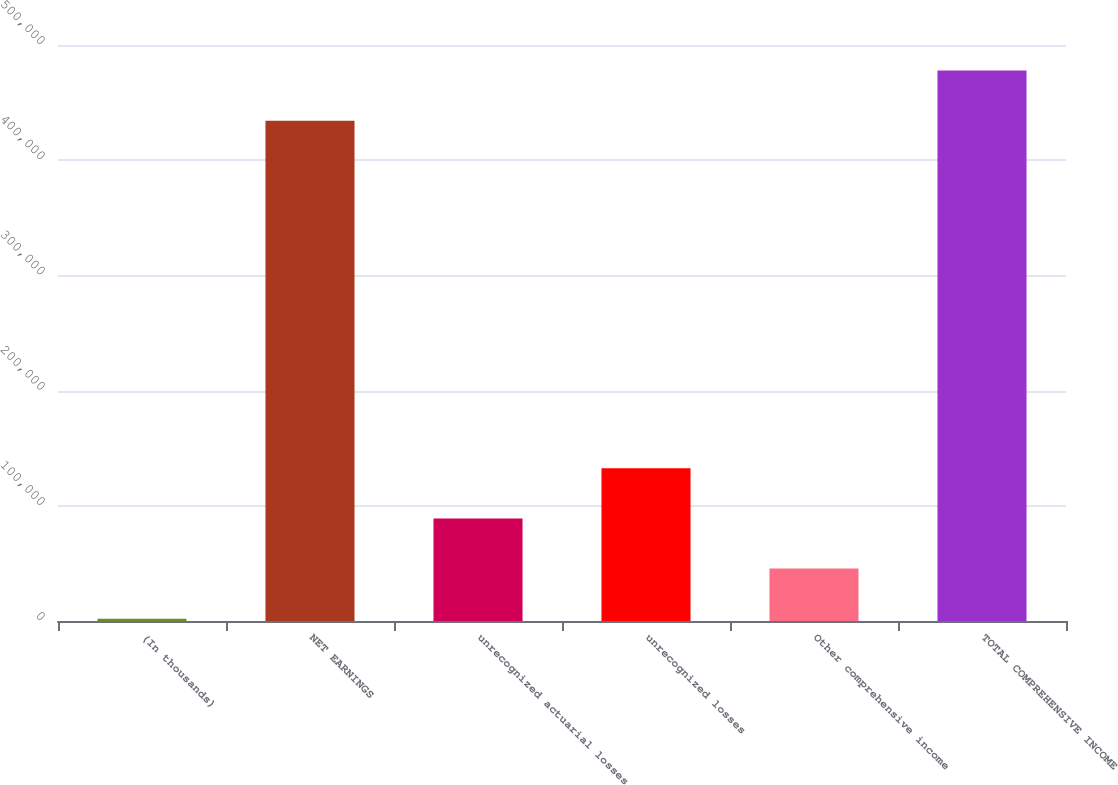<chart> <loc_0><loc_0><loc_500><loc_500><bar_chart><fcel>(In thousands)<fcel>NET EARNINGS<fcel>unrecognized actuarial losses<fcel>unrecognized losses<fcel>Other comprehensive income<fcel>TOTAL COMPREHENSIVE INCOME<nl><fcel>2013<fcel>434284<fcel>88997.4<fcel>132490<fcel>45505.2<fcel>477776<nl></chart> 